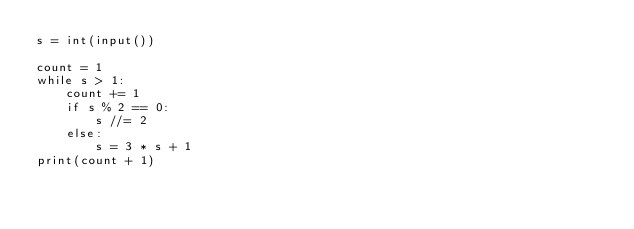<code> <loc_0><loc_0><loc_500><loc_500><_Python_>s = int(input())

count = 1
while s > 1:
    count += 1
    if s % 2 == 0:
        s //= 2
    else:
        s = 3 * s + 1
print(count + 1)</code> 